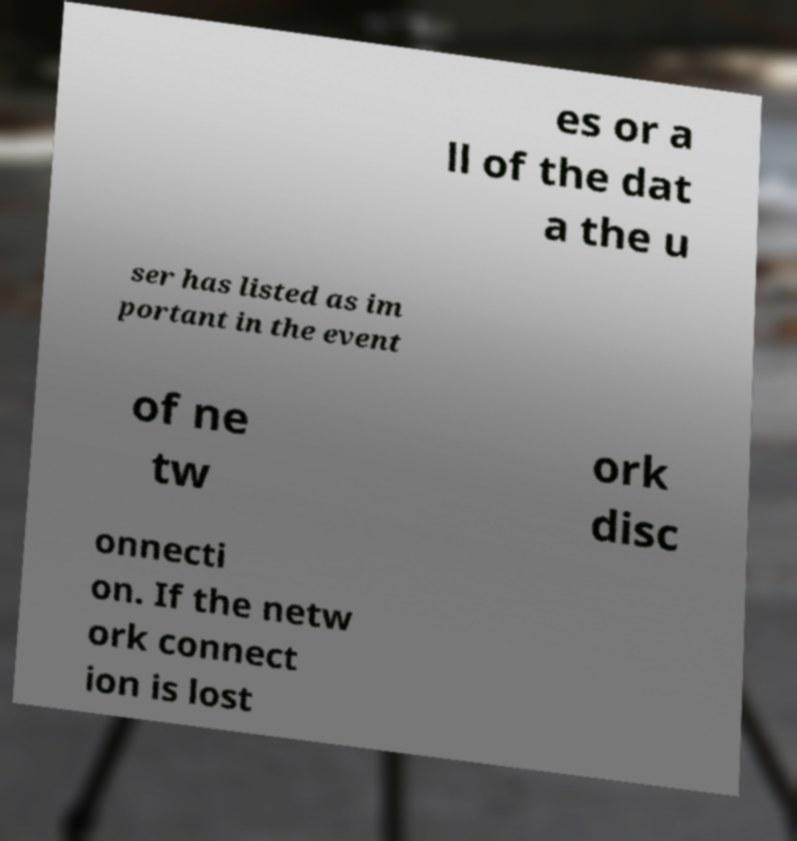Please read and relay the text visible in this image. What does it say? es or a ll of the dat a the u ser has listed as im portant in the event of ne tw ork disc onnecti on. If the netw ork connect ion is lost 